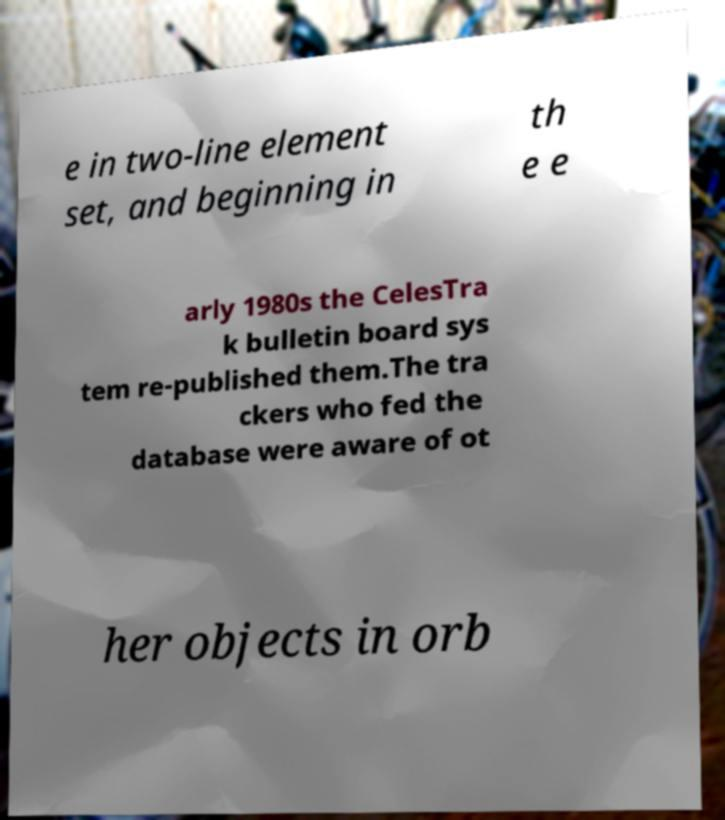Please identify and transcribe the text found in this image. e in two-line element set, and beginning in th e e arly 1980s the CelesTra k bulletin board sys tem re-published them.The tra ckers who fed the database were aware of ot her objects in orb 